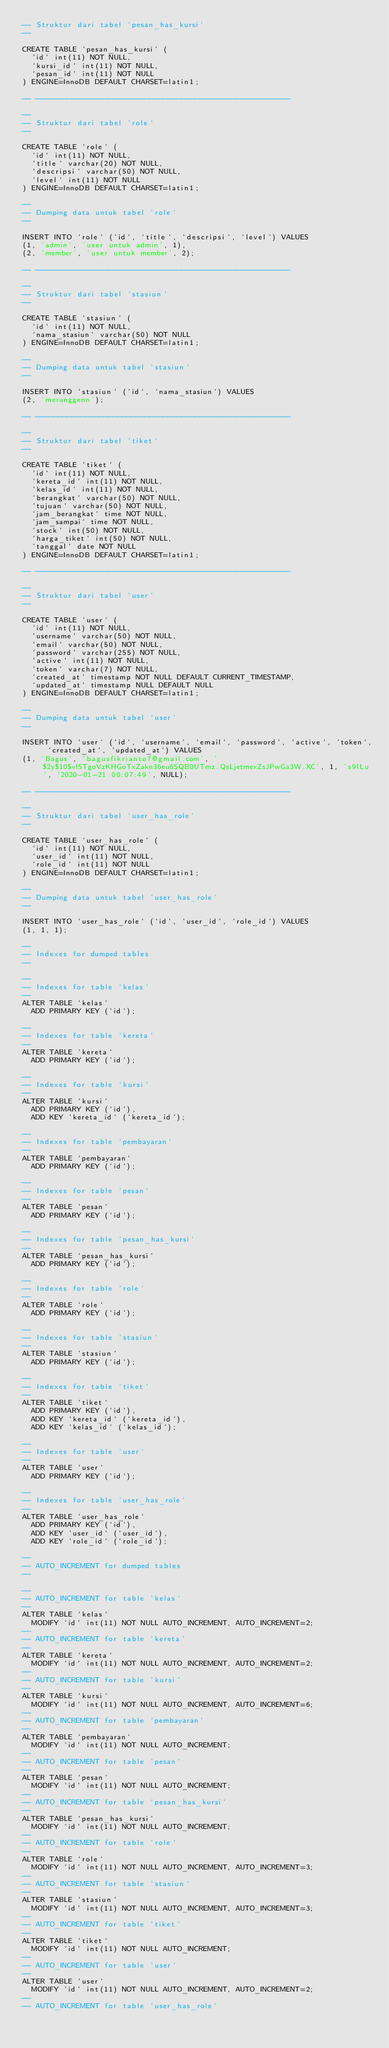Convert code to text. <code><loc_0><loc_0><loc_500><loc_500><_SQL_>-- Struktur dari tabel `pesan_has_kursi`
--

CREATE TABLE `pesan_has_kursi` (
  `id` int(11) NOT NULL,
  `kursi_id` int(11) NOT NULL,
  `pesan_id` int(11) NOT NULL
) ENGINE=InnoDB DEFAULT CHARSET=latin1;

-- --------------------------------------------------------

--
-- Struktur dari tabel `role`
--

CREATE TABLE `role` (
  `id` int(11) NOT NULL,
  `title` varchar(20) NOT NULL,
  `descripsi` varchar(50) NOT NULL,
  `level` int(11) NOT NULL
) ENGINE=InnoDB DEFAULT CHARSET=latin1;

--
-- Dumping data untuk tabel `role`
--

INSERT INTO `role` (`id`, `title`, `descripsi`, `level`) VALUES
(1, 'admin', 'user untuk admin', 1),
(2, 'member', 'user untuk member', 2);

-- --------------------------------------------------------

--
-- Struktur dari tabel `stasiun`
--

CREATE TABLE `stasiun` (
  `id` int(11) NOT NULL,
  `nama_stasiun` varchar(50) NOT NULL
) ENGINE=InnoDB DEFAULT CHARSET=latin1;

--
-- Dumping data untuk tabel `stasiun`
--

INSERT INTO `stasiun` (`id`, `nama_stasiun`) VALUES
(2, 'meranggenn');

-- --------------------------------------------------------

--
-- Struktur dari tabel `tiket`
--

CREATE TABLE `tiket` (
  `id` int(11) NOT NULL,
  `kereta_id` int(11) NOT NULL,
  `kelas_id` int(11) NOT NULL,
  `berangkat` varchar(50) NOT NULL,
  `tujuan` varchar(50) NOT NULL,
  `jam_berangkat` time NOT NULL,
  `jam_sampai` time NOT NULL,
  `stock` int(50) NOT NULL,
  `harga_tiket` int(50) NOT NULL,
  `tanggal` date NOT NULL
) ENGINE=InnoDB DEFAULT CHARSET=latin1;

-- --------------------------------------------------------

--
-- Struktur dari tabel `user`
--

CREATE TABLE `user` (
  `id` int(11) NOT NULL,
  `username` varchar(50) NOT NULL,
  `email` varchar(50) NOT NULL,
  `password` varchar(255) NOT NULL,
  `active` int(11) NOT NULL,
  `token` varchar(7) NOT NULL,
  `created_at` timestamp NOT NULL DEFAULT CURRENT_TIMESTAMP,
  `updated_at` timestamp NULL DEFAULT NULL
) ENGINE=InnoDB DEFAULT CHARSET=latin1;

--
-- Dumping data untuk tabel `user`
--

INSERT INTO `user` (`id`, `username`, `email`, `password`, `active`, `token`, `created_at`, `updated_at`) VALUES
(1, 'Bagus', 'bagusfikrianto7@gmail.com', '$2y$10$vI5TgoVzKHGoTxZakn36eu6SQB0UTmz.QsLjetmexZsJPwGa3W.XC', 1, 's9lLu', '2020-01-21 00:07:49', NULL);

-- --------------------------------------------------------

--
-- Struktur dari tabel `user_has_role`
--

CREATE TABLE `user_has_role` (
  `id` int(11) NOT NULL,
  `user_id` int(11) NOT NULL,
  `role_id` int(11) NOT NULL
) ENGINE=InnoDB DEFAULT CHARSET=latin1;

--
-- Dumping data untuk tabel `user_has_role`
--

INSERT INTO `user_has_role` (`id`, `user_id`, `role_id`) VALUES
(1, 1, 1);

--
-- Indexes for dumped tables
--

--
-- Indexes for table `kelas`
--
ALTER TABLE `kelas`
  ADD PRIMARY KEY (`id`);

--
-- Indexes for table `kereta`
--
ALTER TABLE `kereta`
  ADD PRIMARY KEY (`id`);

--
-- Indexes for table `kursi`
--
ALTER TABLE `kursi`
  ADD PRIMARY KEY (`id`),
  ADD KEY `kereta_id` (`kereta_id`);

--
-- Indexes for table `pembayaran`
--
ALTER TABLE `pembayaran`
  ADD PRIMARY KEY (`id`);

--
-- Indexes for table `pesan`
--
ALTER TABLE `pesan`
  ADD PRIMARY KEY (`id`);

--
-- Indexes for table `pesan_has_kursi`
--
ALTER TABLE `pesan_has_kursi`
  ADD PRIMARY KEY (`id`);

--
-- Indexes for table `role`
--
ALTER TABLE `role`
  ADD PRIMARY KEY (`id`);

--
-- Indexes for table `stasiun`
--
ALTER TABLE `stasiun`
  ADD PRIMARY KEY (`id`);

--
-- Indexes for table `tiket`
--
ALTER TABLE `tiket`
  ADD PRIMARY KEY (`id`),
  ADD KEY `kereta_id` (`kereta_id`),
  ADD KEY `kelas_id` (`kelas_id`);

--
-- Indexes for table `user`
--
ALTER TABLE `user`
  ADD PRIMARY KEY (`id`);

--
-- Indexes for table `user_has_role`
--
ALTER TABLE `user_has_role`
  ADD PRIMARY KEY (`id`),
  ADD KEY `user_id` (`user_id`),
  ADD KEY `role_id` (`role_id`);

--
-- AUTO_INCREMENT for dumped tables
--

--
-- AUTO_INCREMENT for table `kelas`
--
ALTER TABLE `kelas`
  MODIFY `id` int(11) NOT NULL AUTO_INCREMENT, AUTO_INCREMENT=2;
--
-- AUTO_INCREMENT for table `kereta`
--
ALTER TABLE `kereta`
  MODIFY `id` int(11) NOT NULL AUTO_INCREMENT, AUTO_INCREMENT=2;
--
-- AUTO_INCREMENT for table `kursi`
--
ALTER TABLE `kursi`
  MODIFY `id` int(11) NOT NULL AUTO_INCREMENT, AUTO_INCREMENT=6;
--
-- AUTO_INCREMENT for table `pembayaran`
--
ALTER TABLE `pembayaran`
  MODIFY `id` int(11) NOT NULL AUTO_INCREMENT;
--
-- AUTO_INCREMENT for table `pesan`
--
ALTER TABLE `pesan`
  MODIFY `id` int(11) NOT NULL AUTO_INCREMENT;
--
-- AUTO_INCREMENT for table `pesan_has_kursi`
--
ALTER TABLE `pesan_has_kursi`
  MODIFY `id` int(11) NOT NULL AUTO_INCREMENT;
--
-- AUTO_INCREMENT for table `role`
--
ALTER TABLE `role`
  MODIFY `id` int(11) NOT NULL AUTO_INCREMENT, AUTO_INCREMENT=3;
--
-- AUTO_INCREMENT for table `stasiun`
--
ALTER TABLE `stasiun`
  MODIFY `id` int(11) NOT NULL AUTO_INCREMENT, AUTO_INCREMENT=3;
--
-- AUTO_INCREMENT for table `tiket`
--
ALTER TABLE `tiket`
  MODIFY `id` int(11) NOT NULL AUTO_INCREMENT;
--
-- AUTO_INCREMENT for table `user`
--
ALTER TABLE `user`
  MODIFY `id` int(11) NOT NULL AUTO_INCREMENT, AUTO_INCREMENT=2;
--
-- AUTO_INCREMENT for table `user_has_role`</code> 